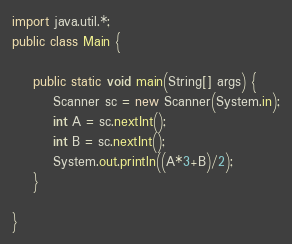Convert code to text. <code><loc_0><loc_0><loc_500><loc_500><_Java_>import java.util.*;
public class Main {

	public static void main(String[] args) {
		Scanner sc = new Scanner(System.in);
		int A = sc.nextInt();
		int B = sc.nextInt();
		System.out.println((A*3+B)/2);
	}

}
</code> 